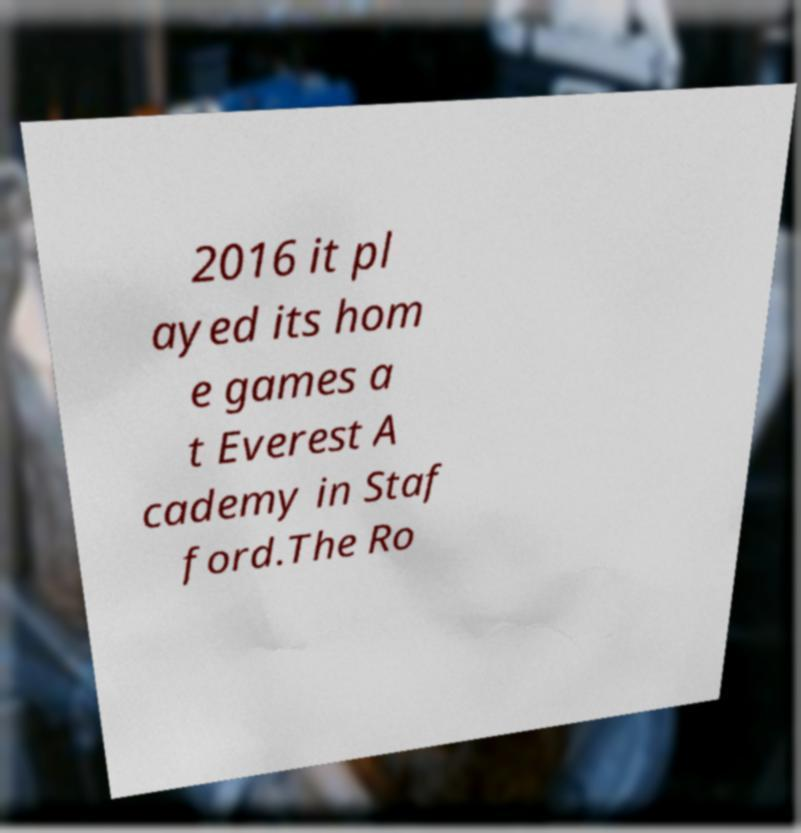I need the written content from this picture converted into text. Can you do that? 2016 it pl ayed its hom e games a t Everest A cademy in Staf ford.The Ro 